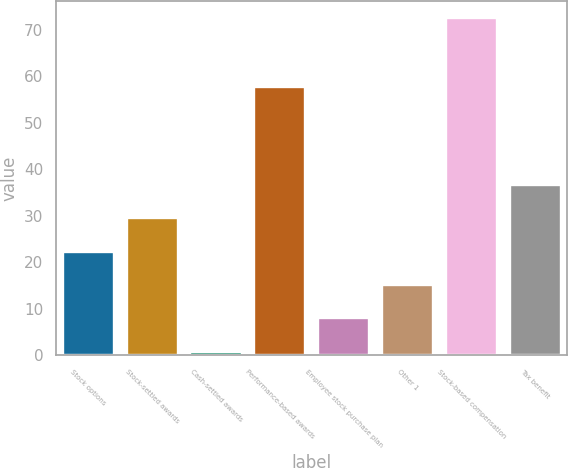Convert chart to OTSL. <chart><loc_0><loc_0><loc_500><loc_500><bar_chart><fcel>Stock options<fcel>Stock-settled awards<fcel>Cash-settled awards<fcel>Performance-based awards<fcel>Employee stock purchase plan<fcel>Other 1<fcel>Stock-based compensation<fcel>Tax benefit<nl><fcel>22.27<fcel>29.46<fcel>0.7<fcel>57.7<fcel>7.89<fcel>15.08<fcel>72.6<fcel>36.65<nl></chart> 